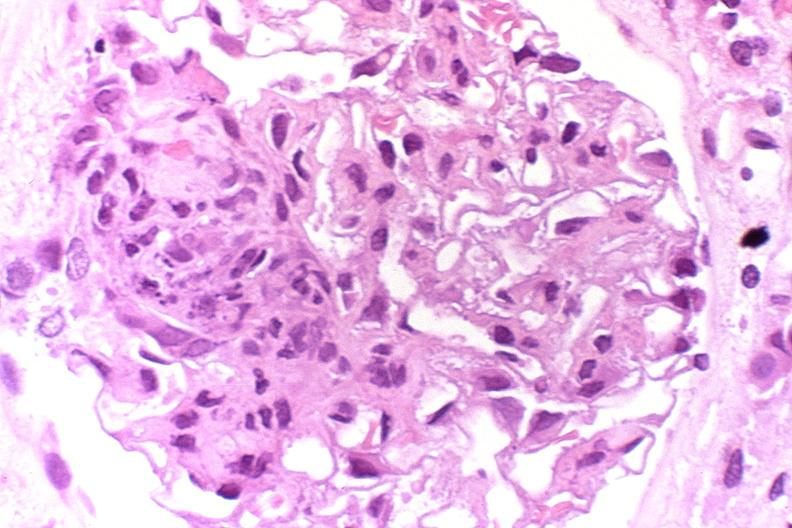s gaucher cell present?
Answer the question using a single word or phrase. No 